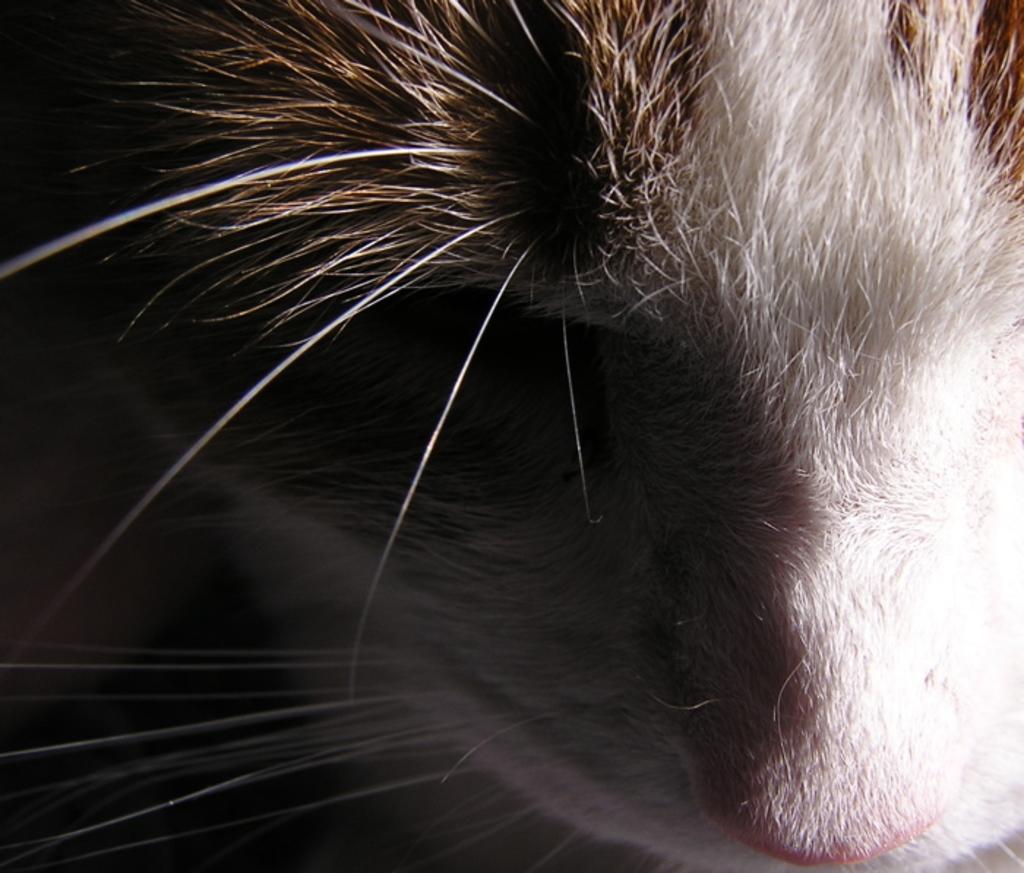Could you give a brief overview of what you see in this image? As we can see in the image there is an animal. 